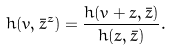<formula> <loc_0><loc_0><loc_500><loc_500>h ( v , \bar { z } ^ { z } ) = \frac { h ( v + z , \bar { z } ) } { h ( z , \bar { z } ) } .</formula> 